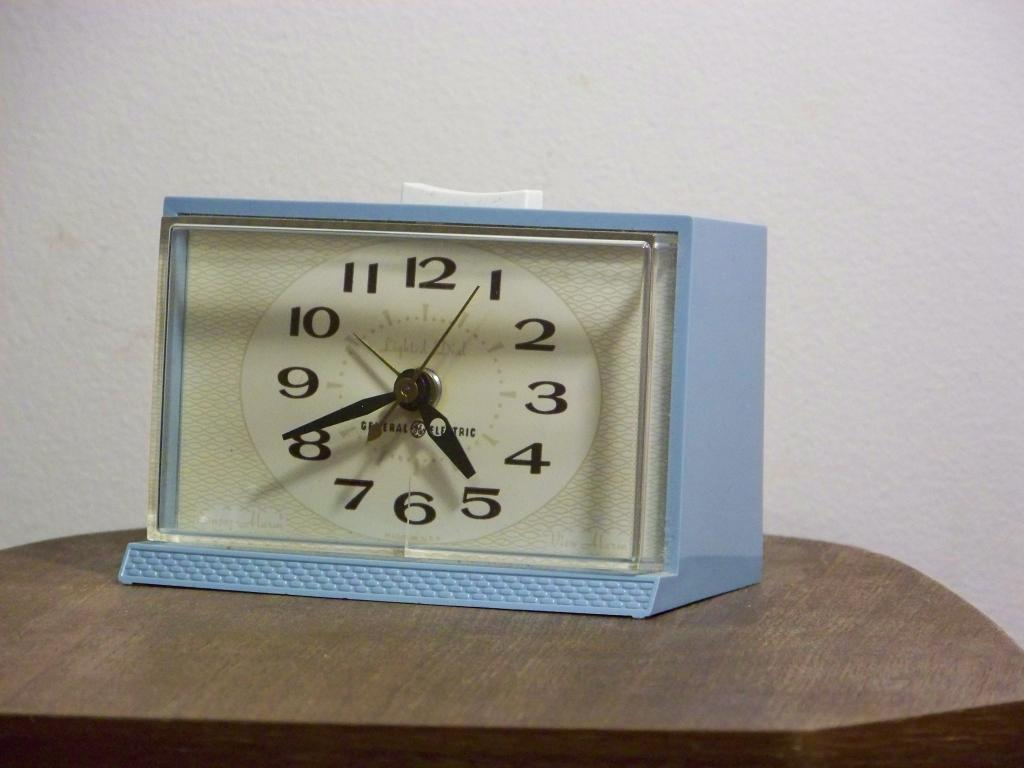<image>
Summarize the visual content of the image. A blue analog table clock with a glass front on a wood table 